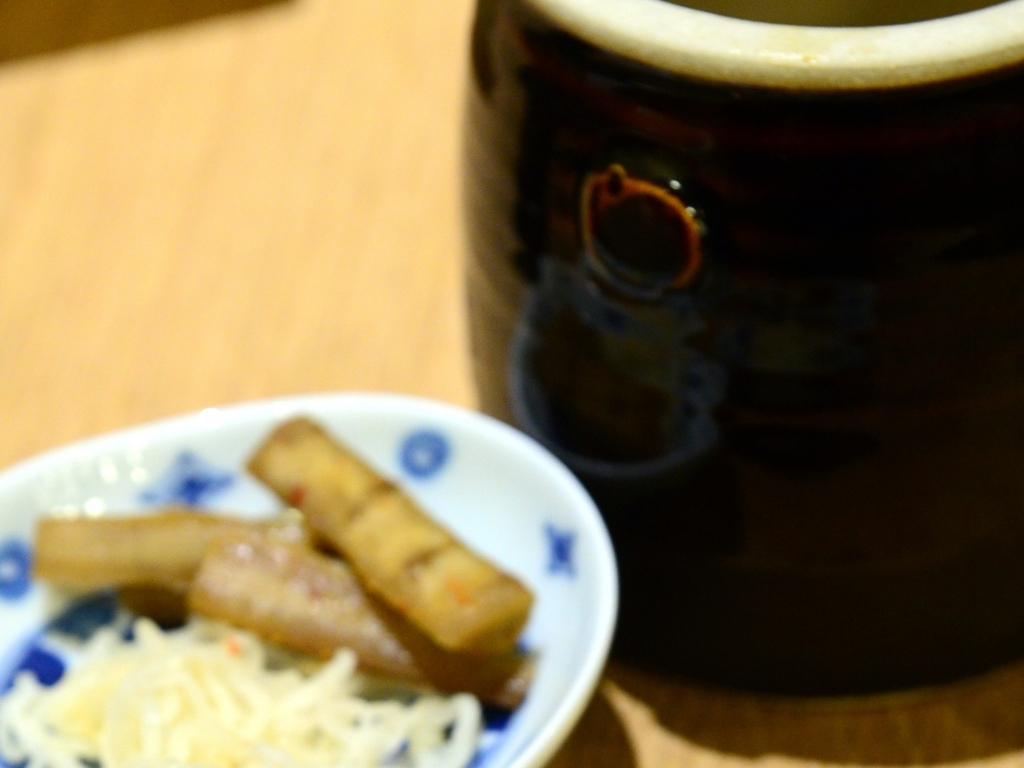What mood or atmosphere does the blurriness of this image evoke? The blurriness of the image gives it a dreamy and ethereal quality. The lack of sharpness can make the scene feel intimate and nostalgic, as if the viewer is recalling a memory that is fading or is part of a moment that is slipping away. The soft focus may elicit a sense of calmness or relaxation, as it softens the details and takes the emphasis away from the content to the overall mood. 